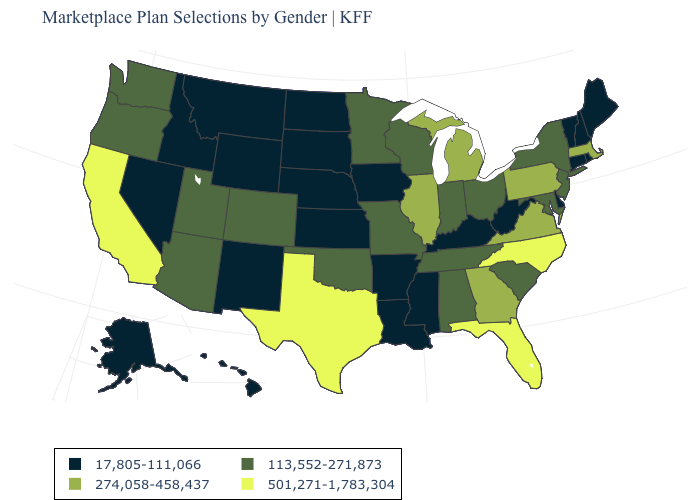Name the states that have a value in the range 113,552-271,873?
Quick response, please. Alabama, Arizona, Colorado, Indiana, Maryland, Minnesota, Missouri, New Jersey, New York, Ohio, Oklahoma, Oregon, South Carolina, Tennessee, Utah, Washington, Wisconsin. Is the legend a continuous bar?
Write a very short answer. No. What is the highest value in the USA?
Short answer required. 501,271-1,783,304. What is the value of New Hampshire?
Write a very short answer. 17,805-111,066. What is the highest value in states that border Missouri?
Keep it brief. 274,058-458,437. What is the highest value in the USA?
Short answer required. 501,271-1,783,304. What is the highest value in the USA?
Short answer required. 501,271-1,783,304. Name the states that have a value in the range 501,271-1,783,304?
Short answer required. California, Florida, North Carolina, Texas. Does the first symbol in the legend represent the smallest category?
Concise answer only. Yes. What is the lowest value in the South?
Be succinct. 17,805-111,066. What is the value of Ohio?
Give a very brief answer. 113,552-271,873. Does Oregon have a lower value than Idaho?
Keep it brief. No. What is the lowest value in states that border Michigan?
Give a very brief answer. 113,552-271,873. Which states have the highest value in the USA?
Short answer required. California, Florida, North Carolina, Texas. What is the value of Arkansas?
Concise answer only. 17,805-111,066. 